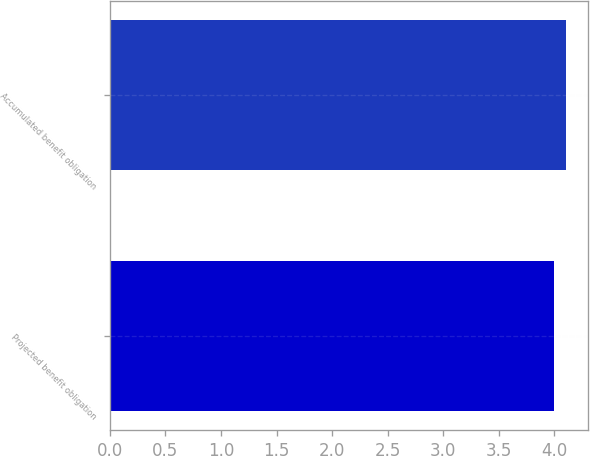Convert chart. <chart><loc_0><loc_0><loc_500><loc_500><bar_chart><fcel>Projected benefit obligation<fcel>Accumulated benefit obligation<nl><fcel>4<fcel>4.1<nl></chart> 